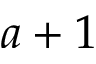Convert formula to latex. <formula><loc_0><loc_0><loc_500><loc_500>a + 1</formula> 